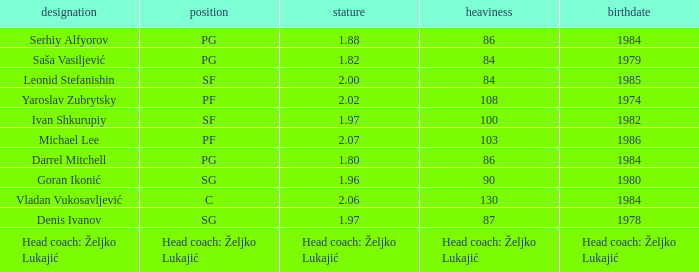Which position did Michael Lee play? PF. 